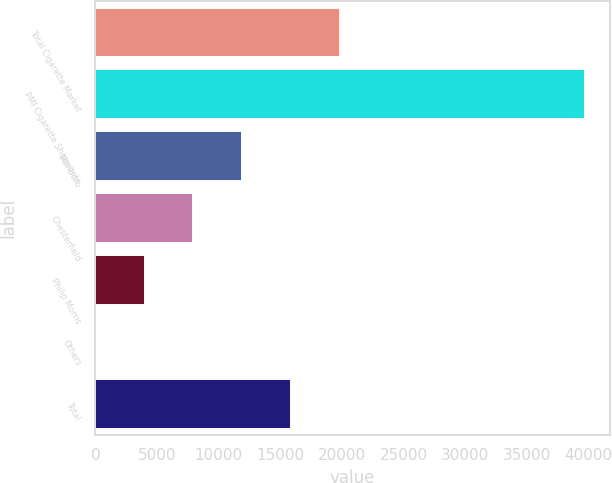Convert chart. <chart><loc_0><loc_0><loc_500><loc_500><bar_chart><fcel>Total Cigarette Market<fcel>PMI Cigarette Shipments<fcel>Marlboro<fcel>Chesterfield<fcel>Philip Morris<fcel>Others<fcel>Total<nl><fcel>19862.9<fcel>39717<fcel>11921.3<fcel>7950.44<fcel>3979.62<fcel>8.8<fcel>15892.1<nl></chart> 